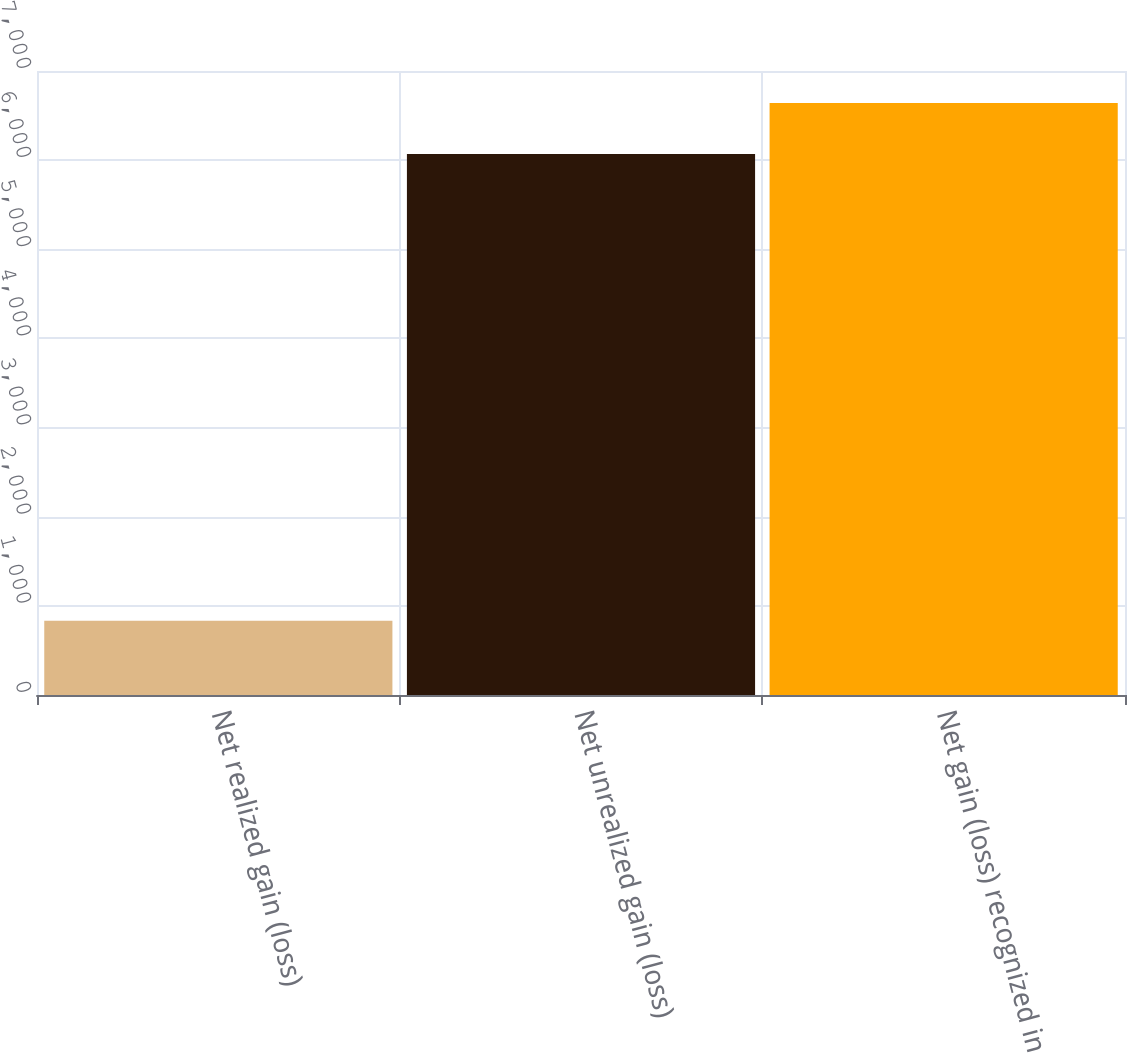Convert chart. <chart><loc_0><loc_0><loc_500><loc_500><bar_chart><fcel>Net realized gain (loss)<fcel>Net unrealized gain (loss)<fcel>Net gain (loss) recognized in<nl><fcel>832<fcel>6070<fcel>6641.4<nl></chart> 